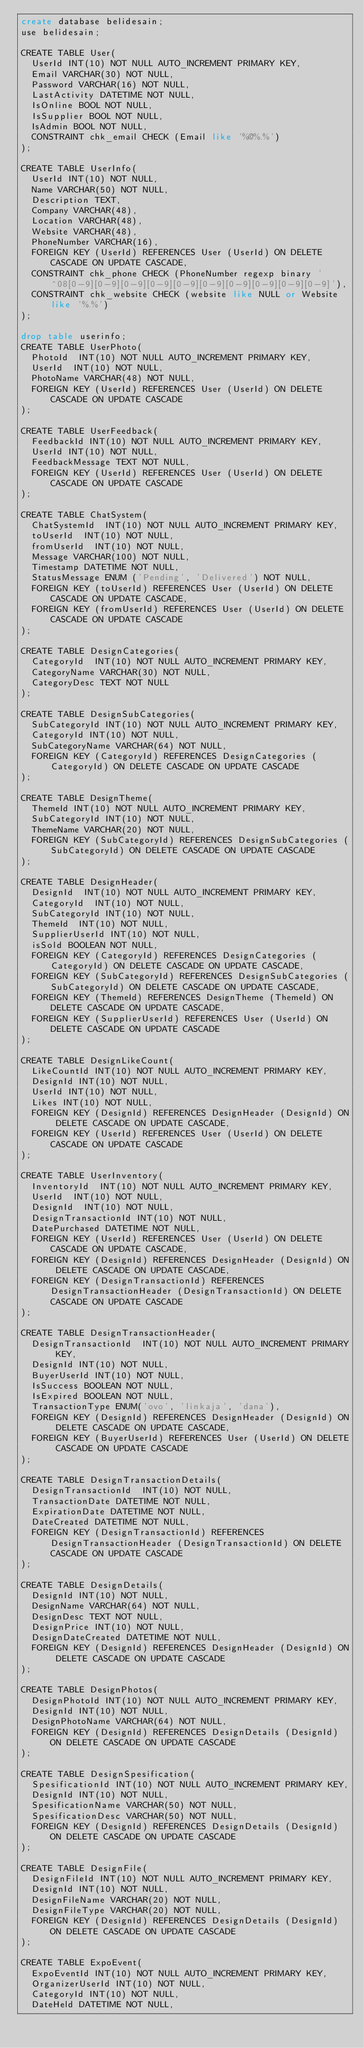Convert code to text. <code><loc_0><loc_0><loc_500><loc_500><_SQL_>create database belidesain;
use belidesain;

CREATE TABLE User(
  UserId INT(10) NOT NULL AUTO_INCREMENT PRIMARY KEY,
  Email VARCHAR(30) NOT NULL,
  Password VARCHAR(16) NOT NULL,
  LastActivity DATETIME NOT NULL,
  IsOnline BOOL NOT NULL,
  IsSupplier BOOL NOT NULL,
  IsAdmin BOOL NOT NULL,
  CONSTRAINT chk_email CHECK (Email like '%@%.%')
);

CREATE TABLE UserInfo(
  UserId INT(10) NOT NULL,
  Name VARCHAR(50) NOT NULL,
  Description TEXT,
  Company VARCHAR(48),
  Location VARCHAR(48),
  Website VARCHAR(48),
  PhoneNumber VARCHAR(16),
  FOREIGN KEY (UserId) REFERENCES User (UserId) ON DELETE CASCADE ON UPDATE CASCADE,
  CONSTRAINT chk_phone CHECK (PhoneNumber regexp binary '^08[0-9][0-9][0-9][0-9][0-9][0-9][0-9][0-9][0-9][0-9]'),
  CONSTRAINT chk_website CHECK (website like NULL or Website like '%.%')
);

drop table userinfo;
CREATE TABLE UserPhoto(
  PhotoId  INT(10) NOT NULL AUTO_INCREMENT PRIMARY KEY,
  UserId  INT(10) NOT NULL,
  PhotoName VARCHAR(48) NOT NULL,
  FOREIGN KEY (UserId) REFERENCES User (UserId) ON DELETE CASCADE ON UPDATE CASCADE
);

CREATE TABLE UserFeedback(
  FeedbackId INT(10) NOT NULL AUTO_INCREMENT PRIMARY KEY,
  UserId INT(10) NOT NULL,
  FeedbackMessage TEXT NOT NULL,
  FOREIGN KEY (UserId) REFERENCES User (UserId) ON DELETE CASCADE ON UPDATE CASCADE
);

CREATE TABLE ChatSystem(
  ChatSystemId  INT(10) NOT NULL AUTO_INCREMENT PRIMARY KEY,
  toUserId  INT(10) NOT NULL,
  fromUserId  INT(10) NOT NULL,
  Message VARCHAR(100) NOT NULL,
  Timestamp DATETIME NOT NULL,
  StatusMessage ENUM ('Pending', 'Delivered') NOT NULL,
  FOREIGN KEY (toUserId) REFERENCES User (UserId) ON DELETE CASCADE ON UPDATE CASCADE,
  FOREIGN KEY (fromUserId) REFERENCES User (UserId) ON DELETE CASCADE ON UPDATE CASCADE
);

CREATE TABLE DesignCategories(
  CategoryId  INT(10) NOT NULL AUTO_INCREMENT PRIMARY KEY,
  CategoryName VARCHAR(30) NOT NULL,
  CategoryDesc TEXT NOT NULL
);

CREATE TABLE DesignSubCategories(
  SubCategoryId INT(10) NOT NULL AUTO_INCREMENT PRIMARY KEY,
  CategoryId INT(10) NOT NULL,
  SubCategoryName VARCHAR(64) NOT NULL,
  FOREIGN KEY (CategoryId) REFERENCES DesignCategories (CategoryId) ON DELETE CASCADE ON UPDATE CASCADE
);

CREATE TABLE DesignTheme(
  ThemeId INT(10) NOT NULL AUTO_INCREMENT PRIMARY KEY,
  SubCategoryId INT(10) NOT NULL,
  ThemeName VARCHAR(20) NOT NULL,
  FOREIGN KEY (SubCategoryId) REFERENCES DesignSubCategories (SubCategoryId) ON DELETE CASCADE ON UPDATE CASCADE
);

CREATE TABLE DesignHeader(
  DesignId  INT(10) NOT NULL AUTO_INCREMENT PRIMARY KEY,
  CategoryId  INT(10) NOT NULL,
  SubCategoryId INT(10) NOT NULL,
  ThemeId  INT(10) NOT NULL,
  SupplierUserId INT(10) NOT NULL,
  isSold BOOLEAN NOT NULL,
  FOREIGN KEY (CategoryId) REFERENCES DesignCategories (CategoryId) ON DELETE CASCADE ON UPDATE CASCADE,
  FOREIGN KEY (SubCategoryId) REFERENCES DesignSubCategories (SubCategoryId) ON DELETE CASCADE ON UPDATE CASCADE,
  FOREIGN KEY (ThemeId) REFERENCES DesignTheme (ThemeId) ON DELETE CASCADE ON UPDATE CASCADE,
  FOREIGN KEY (SupplierUserId) REFERENCES User (UserId) ON DELETE CASCADE ON UPDATE CASCADE
);

CREATE TABLE DesignLikeCount(
  LikeCountId INT(10) NOT NULL AUTO_INCREMENT PRIMARY KEY,
  DesignId INT(10) NOT NULL,
  UserId INT(10) NOT NULL,
  Likes INT(10) NOT NULL,
  FOREIGN KEY (DesignId) REFERENCES DesignHeader (DesignId) ON DELETE CASCADE ON UPDATE CASCADE,
  FOREIGN KEY (UserId) REFERENCES User (UserId) ON DELETE CASCADE ON UPDATE CASCADE
);

CREATE TABLE UserInventory(
  InventoryId  INT(10) NOT NULL AUTO_INCREMENT PRIMARY KEY,
  UserId  INT(10) NOT NULL,
  DesignId  INT(10) NOT NULL,
  DesignTransactionId INT(10) NOT NULL,
  DatePurchased DATETIME NOT NULL,
  FOREIGN KEY (UserId) REFERENCES User (UserId) ON DELETE CASCADE ON UPDATE CASCADE,
  FOREIGN KEY (DesignId) REFERENCES DesignHeader (DesignId) ON DELETE CASCADE ON UPDATE CASCADE,
  FOREIGN KEY (DesignTransactionId) REFERENCES DesignTransactionHeader (DesignTransactionId) ON DELETE CASCADE ON UPDATE CASCADE
);

CREATE TABLE DesignTransactionHeader(
  DesignTransactionId  INT(10) NOT NULL AUTO_INCREMENT PRIMARY KEY,
  DesignId INT(10) NOT NULL,
  BuyerUserId INT(10) NOT NULL,
  IsSuccess BOOLEAN NOT NULL,
  IsExpired BOOLEAN NOT NULL,
  TransactionType ENUM('ovo', 'linkaja', 'dana'),
  FOREIGN KEY (DesignId) REFERENCES DesignHeader (DesignId) ON DELETE CASCADE ON UPDATE CASCADE,
  FOREIGN KEY (BuyerUserId) REFERENCES User (UserId) ON DELETE CASCADE ON UPDATE CASCADE
);

CREATE TABLE DesignTransactionDetails(
  DesignTransactionId  INT(10) NOT NULL,
  TransactionDate DATETIME NOT NULL,
  ExpirationDate DATETIME NOT NULL,
  DateCreated DATETIME NOT NULL,
  FOREIGN KEY (DesignTransactionId) REFERENCES DesignTransactionHeader (DesignTransactionId) ON DELETE CASCADE ON UPDATE CASCADE
);

CREATE TABLE DesignDetails(
  DesignId INT(10) NOT NULL,
  DesignName VARCHAR(64) NOT NULL,
  DesignDesc TEXT NOT NULL,
  DesignPrice INT(10) NOT NULL,
  DesignDateCreated DATETIME NOT NULL,
  FOREIGN KEY (DesignId) REFERENCES DesignHeader (DesignId) ON DELETE CASCADE ON UPDATE CASCADE
);

CREATE TABLE DesignPhotos(
  DesignPhotoId INT(10) NOT NULL AUTO_INCREMENT PRIMARY KEY,
  DesignId INT(10) NOT NULL,
  DesignPhotoName VARCHAR(64) NOT NULL,
  FOREIGN KEY (DesignId) REFERENCES DesignDetails (DesignId) ON DELETE CASCADE ON UPDATE CASCADE
);

CREATE TABLE DesignSpesification(
  SpesificationId INT(10) NOT NULL AUTO_INCREMENT PRIMARY KEY,
  DesignId INT(10) NOT NULL,
  SpesificationName VARCHAR(50) NOT NULL,
  SpesificationDesc VARCHAR(50) NOT NULL,
  FOREIGN KEY (DesignId) REFERENCES DesignDetails (DesignId) ON DELETE CASCADE ON UPDATE CASCADE
);

CREATE TABLE DesignFile(
  DesignFileId INT(10) NOT NULL AUTO_INCREMENT PRIMARY KEY,
  DesignId INT(10) NOT NULL,
  DesignFileName VARCHAR(20) NOT NULL,
  DesignFileType VARCHAR(20) NOT NULL,
  FOREIGN KEY (DesignId) REFERENCES DesignDetails (DesignId) ON DELETE CASCADE ON UPDATE CASCADE
);

CREATE TABLE ExpoEvent(
  ExpoEventId INT(10) NOT NULL AUTO_INCREMENT PRIMARY KEY,
  OrganizerUserId INT(10) NOT NULL,
  CategoryId INT(10) NOT NULL,
  DateHeld DATETIME NOT NULL,</code> 